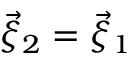<formula> <loc_0><loc_0><loc_500><loc_500>\vec { \xi } _ { 2 } = \vec { \xi } _ { 1 }</formula> 